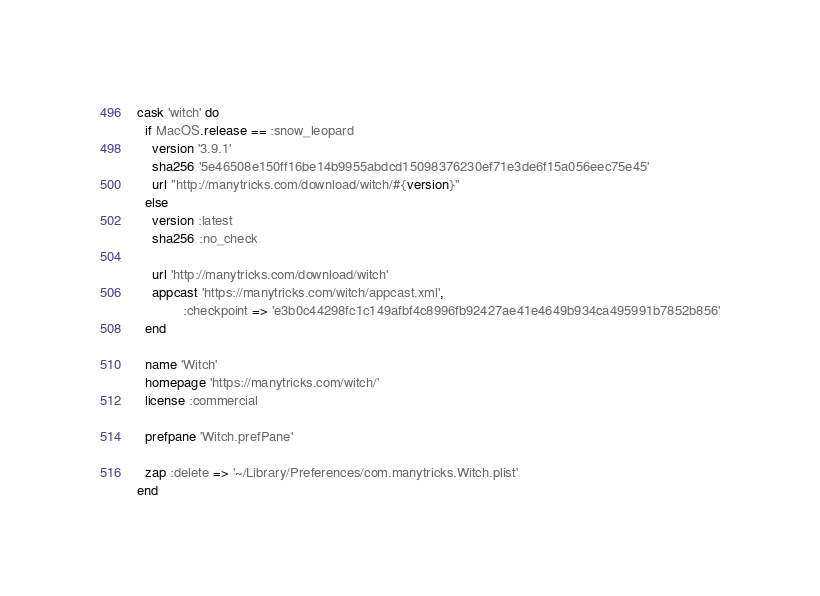Convert code to text. <code><loc_0><loc_0><loc_500><loc_500><_Ruby_>cask 'witch' do
  if MacOS.release == :snow_leopard
    version '3.9.1'
    sha256 '5e46508e150ff16be14b9955abdcd15098376230ef71e3de6f15a056eec75e45'
    url "http://manytricks.com/download/witch/#{version}"
  else
    version :latest
    sha256 :no_check

    url 'http://manytricks.com/download/witch'
    appcast 'https://manytricks.com/witch/appcast.xml',
            :checkpoint => 'e3b0c44298fc1c149afbf4c8996fb92427ae41e4649b934ca495991b7852b856'
  end

  name 'Witch'
  homepage 'https://manytricks.com/witch/'
  license :commercial

  prefpane 'Witch.prefPane'

  zap :delete => '~/Library/Preferences/com.manytricks.Witch.plist'
end
</code> 